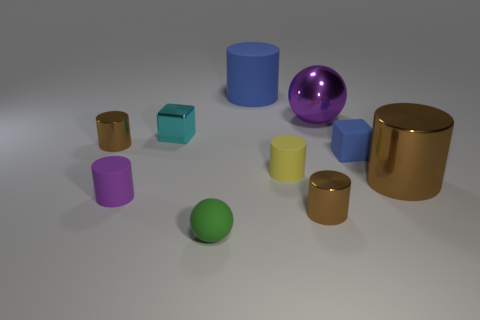Subtract all cyan spheres. How many brown cylinders are left? 3 Subtract all blue cylinders. How many cylinders are left? 5 Subtract all blue cylinders. How many cylinders are left? 5 Subtract all red cylinders. Subtract all red blocks. How many cylinders are left? 6 Subtract all spheres. How many objects are left? 8 Subtract all brown shiny things. Subtract all purple things. How many objects are left? 5 Add 3 tiny cyan shiny objects. How many tiny cyan shiny objects are left? 4 Add 8 large metallic balls. How many large metallic balls exist? 9 Subtract 1 blue cylinders. How many objects are left? 9 